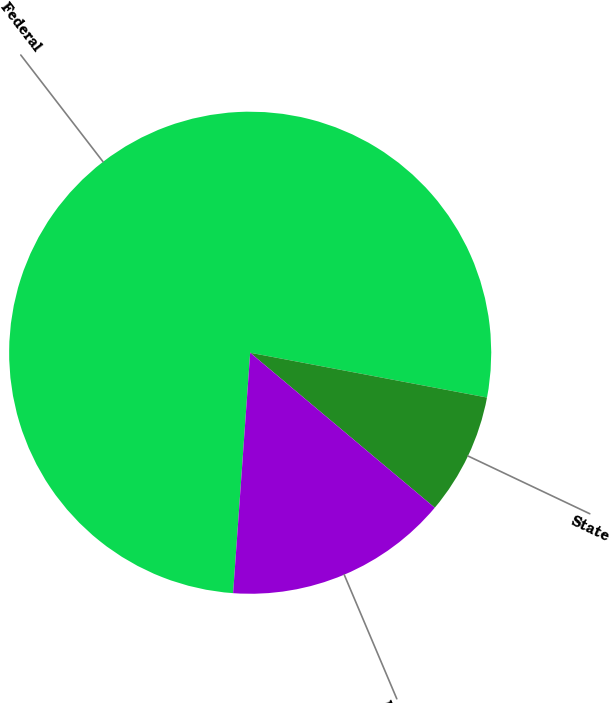Convert chart. <chart><loc_0><loc_0><loc_500><loc_500><pie_chart><fcel>Federal<fcel>State<fcel>Deferred<nl><fcel>76.84%<fcel>8.14%<fcel>15.01%<nl></chart> 